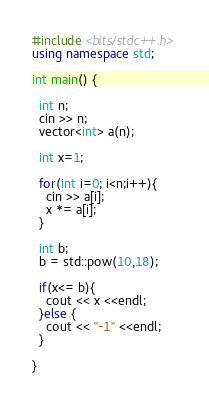Convert code to text. <code><loc_0><loc_0><loc_500><loc_500><_C++_>#include <bits/stdc++.h>
using namespace std;

int main() {
  
  int n;
  cin >> n;
  vector<int> a(n);
  
  int x=1;
  
  for(int i=0; i<n;i++){
    cin >> a[i];
    x *= a[i];
  }

  int b;
  b = std::pow(10,18);
  
  if(x<= b){
    cout << x <<endl;
  }else {
    cout << "-1" <<endl;
  }
  
}
</code> 